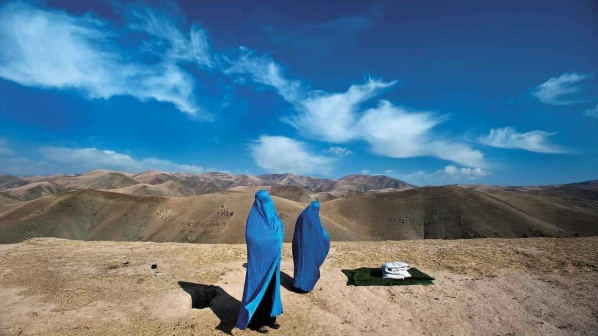What do you think the women might be discussing in this serene environment? Given the tranquil setting and the close proximity of the women, they might be sharing personal stories, discussing matters of their journey, or reflecting on the beauty of the landscape surrounding them. The serene environment could inspire heartfelt conversations about life, nature, and the shared experiences they have together. It could also be a moment of silent contemplation and mutual understanding, where words are secondary to the experience of the moment. 